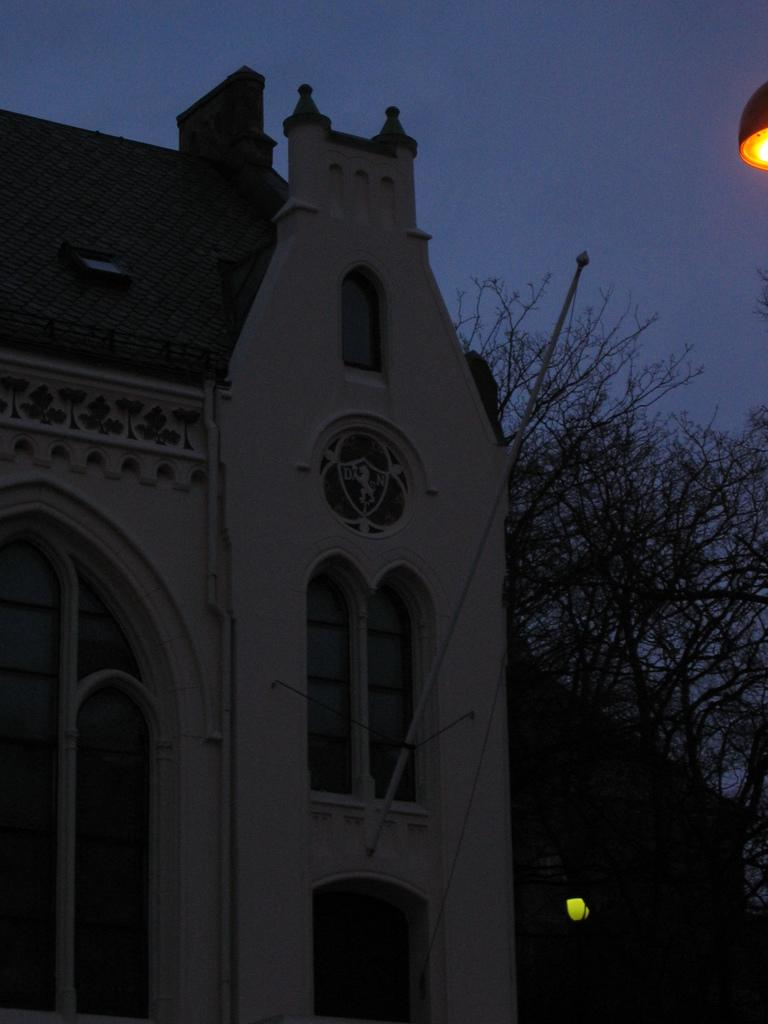What type of structure is visible in the image? There is a building in the image. What can be seen on the right side of the image? There is a tree and a light on the right side of the image. What is visible in the background of the image? The sky is visible in the background of the image. What type of bait is being used to attract customers to the building in the image? There are no bait, or customers mentioned in the image; it only shows a building, a tree, a light, and the sky. 